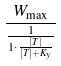<formula> <loc_0><loc_0><loc_500><loc_500>\frac { W _ { \max } } { \frac { 1 } { 1 \cdot \frac { [ T ] } { [ T ] + K _ { y } } } }</formula> 